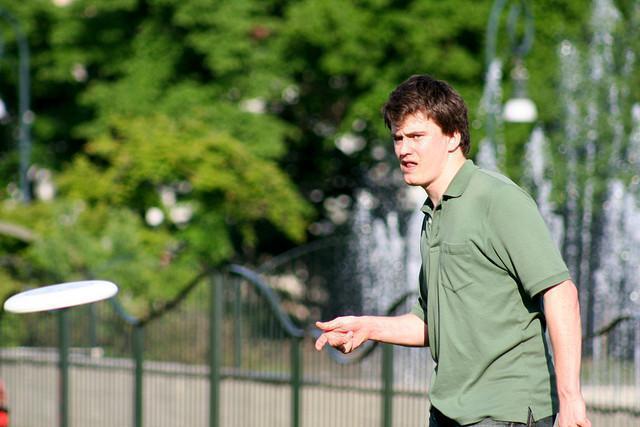The color of the shirt matches the color of what?
Choose the right answer from the provided options to respond to the question.
Options: Sky, peaches, elephants, money. Money. 